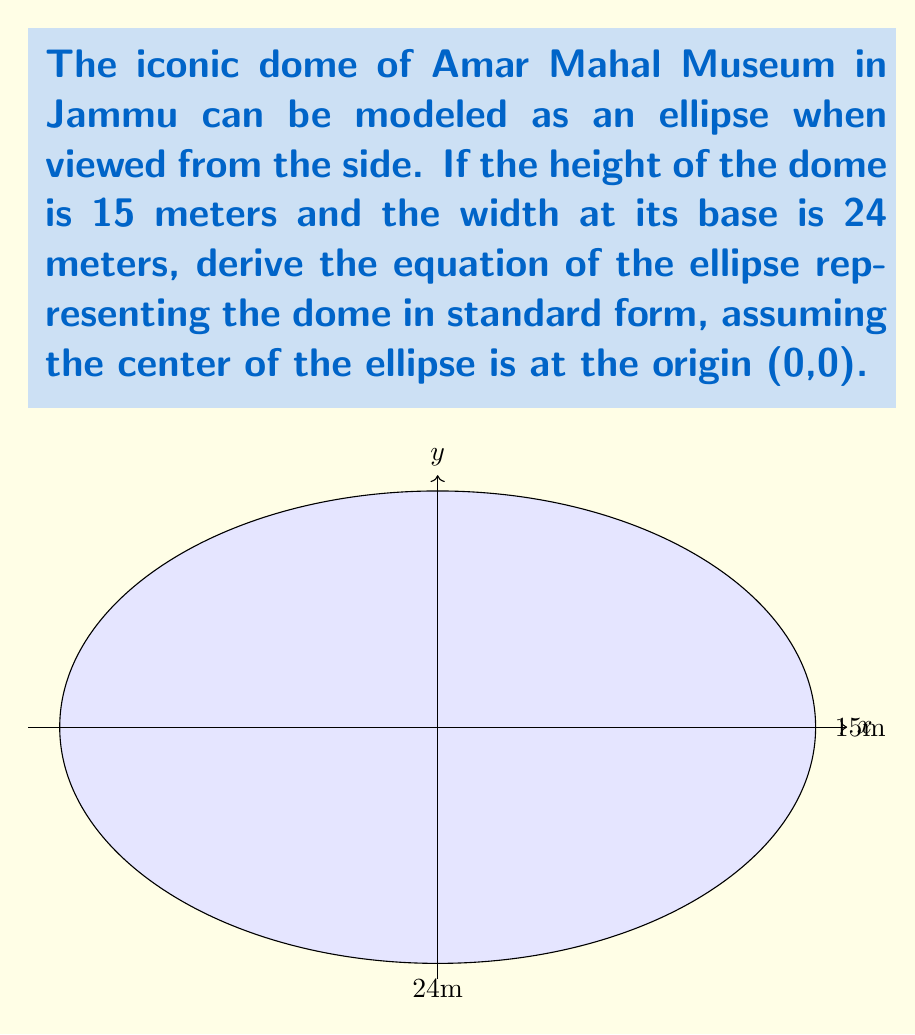Solve this math problem. Let's approach this step-by-step:

1) The standard form of an ellipse centered at the origin is:

   $$\frac{x^2}{a^2} + \frac{y^2}{b^2} = 1$$

   where $a$ is the length of the semi-major axis and $b$ is the length of the semi-minor axis.

2) From the given information:
   - The width of the dome is 24 meters, so the horizontal semi-axis $a = 12$ meters
   - The height of the dome is 15 meters, so the vertical semi-axis $b = 7.5$ meters

3) Substituting these values into the standard form:

   $$\frac{x^2}{12^2} + \frac{y^2}{7.5^2} = 1$$

4) Simplify by squaring the denominators:

   $$\frac{x^2}{144} + \frac{y^2}{56.25} = 1$$

5) To remove fractions, multiply both sides by 144 (the LCM of 144 and 56.25):

   $$x^2 + \frac{144}{56.25}y^2 = 144$$

6) Simplify the fraction:

   $$x^2 + \frac{256}{100}y^2 = 144$$

7) Further simplify:

   $$x^2 + \frac{64}{25}y^2 = 144$$

This is the final equation of the ellipse representing the dome of Amar Mahal Museum in standard form.
Answer: $$x^2 + \frac{64}{25}y^2 = 144$$ 